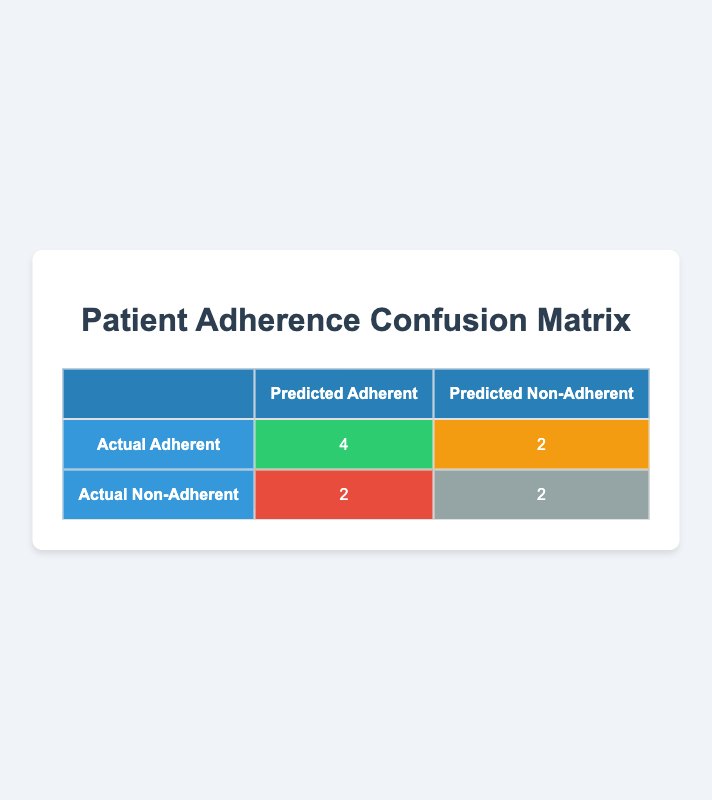What is the number of true positives in the confusion matrix? The true positives, represented by the cell where predicted adherent and actual adherent intersect, is 4 according to the table.
Answer: 4 How many patients were predicted as non-adherent but were actually adherent? This figure represents the false negatives, which is found in the cell where predicted non-adherent intersects with actual adherent. From the table, that number is 2.
Answer: 2 What is the number of true negatives in the confusion matrix? The true negatives are located in the cell where both predicted non-adherent and actual non-adherent meet, which shows a count of 2 in the table.
Answer: 2 What is the total count of patients classified as adherent in both predicted and actual terms? To find this, we need to add the true positives (4) and false negatives (2) for the actual adherent classification: 4 + 2 = 6.
Answer: 6 Is the number of false positives greater than the number of true negatives? The false positives count is 2, while the true negatives count is also 2. Since they are equal, the statement is false.
Answer: No What is the total count of predicted non-adherent patients? This includes false positives (2) and true negatives (2), summing to 2 + 2 = 4 for predicted non-adherent patients.
Answer: 4 Which patient group (adherent or non-adherent) has a higher count of misclassification? Misclassification occurs when true adherents are predicted as non-adherent (false negatives = 2) and true non-adherents are predicted as adherent (false positives = 2). Since both counts are the same, there is no higher count in either group.
Answer: Neither What is the accuracy of the predictions based on the confusion matrix? Accuracy is determined by the formula (True Positives + True Negatives) / Total Patients. Thus, (4 + 2) / 10 = 0.6, indicating 60 percent accuracy.
Answer: 60% How many total patients were actually adherent? This corresponds to true positives and false negatives: 4 (true positives) + 2 (false negatives) = 6 actual adherent patients.
Answer: 6 